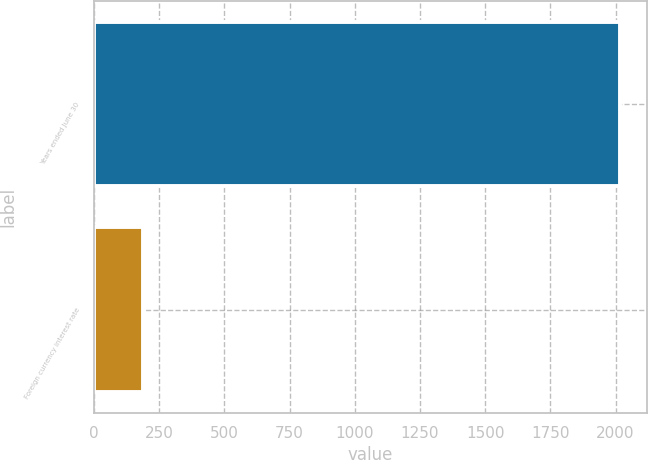<chart> <loc_0><loc_0><loc_500><loc_500><bar_chart><fcel>Years ended June 30<fcel>Foreign currency interest rate<nl><fcel>2018<fcel>187<nl></chart> 